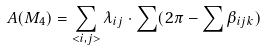<formula> <loc_0><loc_0><loc_500><loc_500>A ( M _ { 4 } ) = \sum _ { < i , j > } \lambda _ { i j } \cdot \sum ( 2 \pi - \sum \beta _ { i j k } )</formula> 